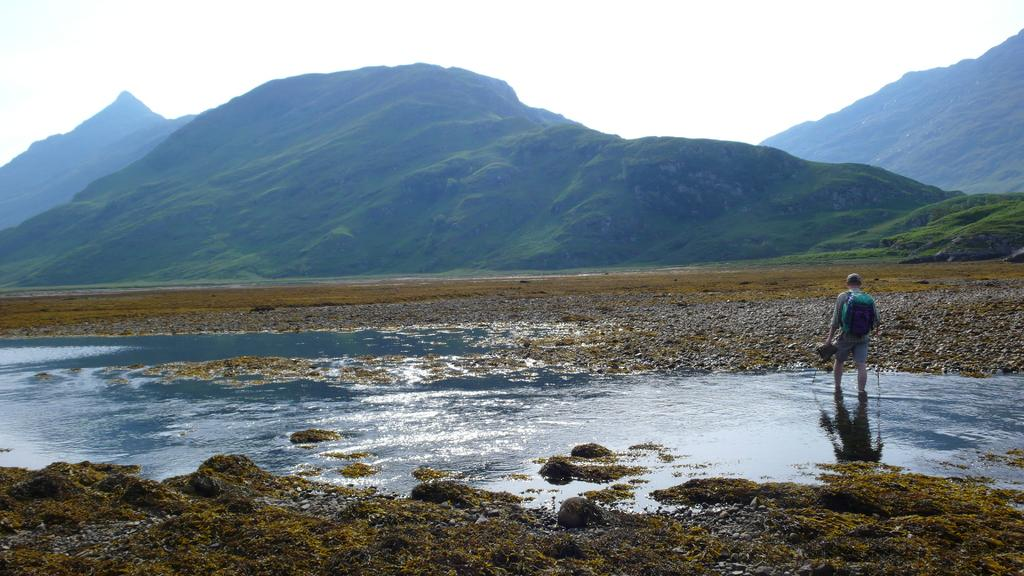What is the main subject of the image? There is a man standing in the image. Where is the man located in relation to the pond? The man is standing on the right side of the pond. What can be seen in the background of the image? Hills are visible in the background of the image. What type of vegetation is present on the hills? The hills have grass and plants on them. What is visible above the hills? The sky is visible above the hills. What type of door can be seen on the pond in the image? There is no door present on the pond in the image. What is the man transporting in the image? The image does not show the man transporting anything. 